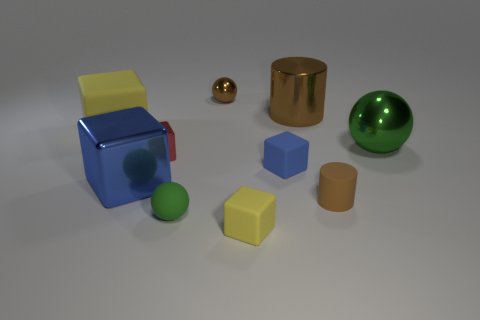Are there the same number of tiny green things that are to the right of the small brown metallic thing and large blue metal cubes?
Give a very brief answer. No. How many big yellow matte cubes are to the left of the large yellow cube?
Offer a very short reply. 0. The blue rubber object has what size?
Offer a terse response. Small. The big cube that is the same material as the brown ball is what color?
Provide a short and direct response. Blue. How many gray cubes have the same size as the brown metal sphere?
Keep it short and to the point. 0. Is the material of the green sphere that is behind the small blue rubber block the same as the big blue thing?
Provide a succinct answer. Yes. Is the number of blue matte objects left of the big blue shiny object less than the number of things?
Offer a very short reply. Yes. What is the shape of the yellow thing in front of the tiny red object?
Your answer should be compact. Cube. The blue matte thing that is the same size as the brown rubber cylinder is what shape?
Give a very brief answer. Cube. Are there any brown metallic things of the same shape as the green metal thing?
Provide a succinct answer. Yes. 